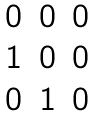<formula> <loc_0><loc_0><loc_500><loc_500>\begin{matrix} 0 & 0 & 0 \\ 1 & 0 & 0 \\ 0 & 1 & 0 \end{matrix}</formula> 